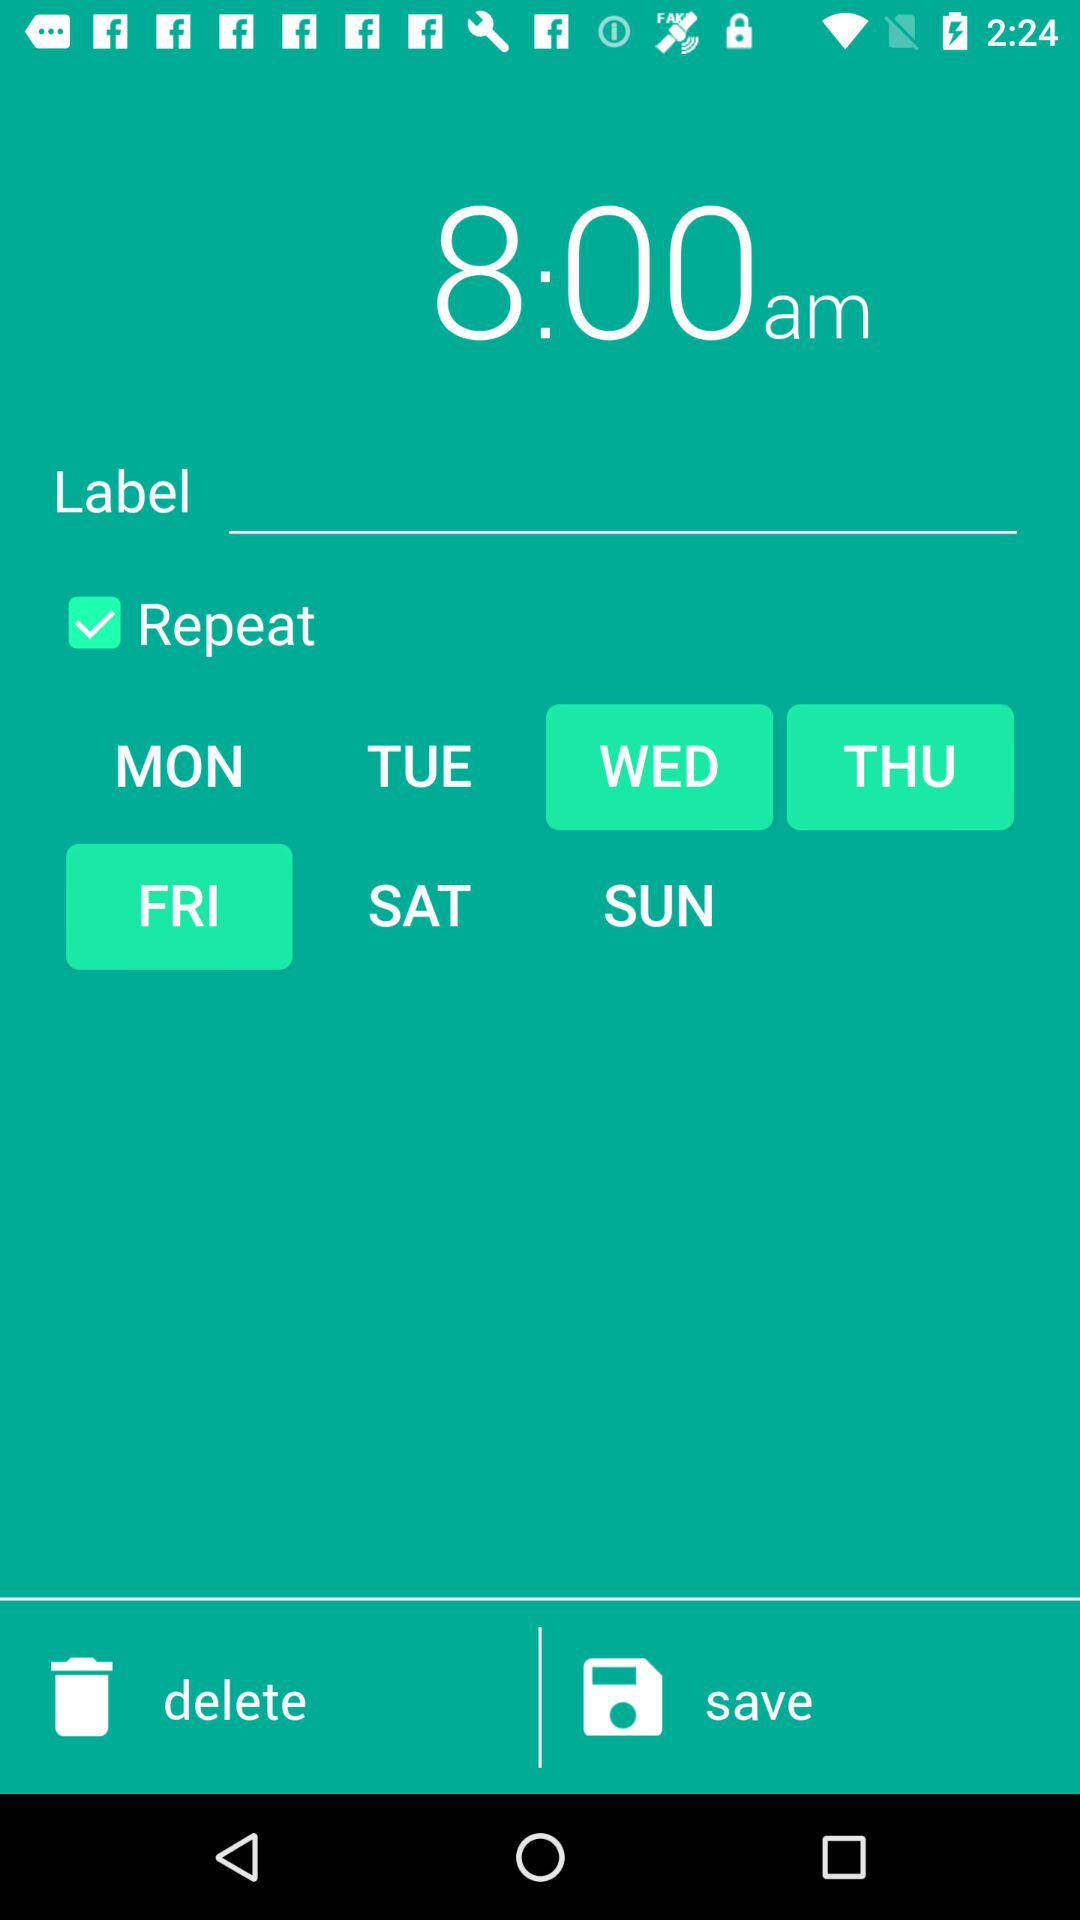What time has been selected? The selected time is 8:00 a.m. 